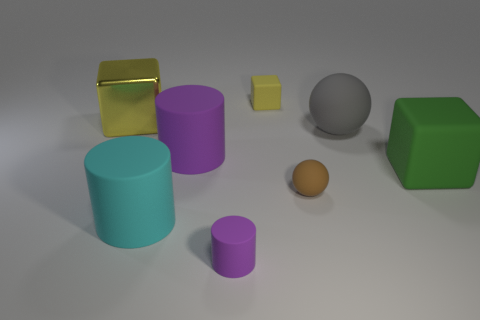Does the large cyan cylinder have the same material as the big yellow object? No, the large cyan cylinder appears to have a matte finish, while the big yellow object has a reflective surface, indicating they're made of different materials. 